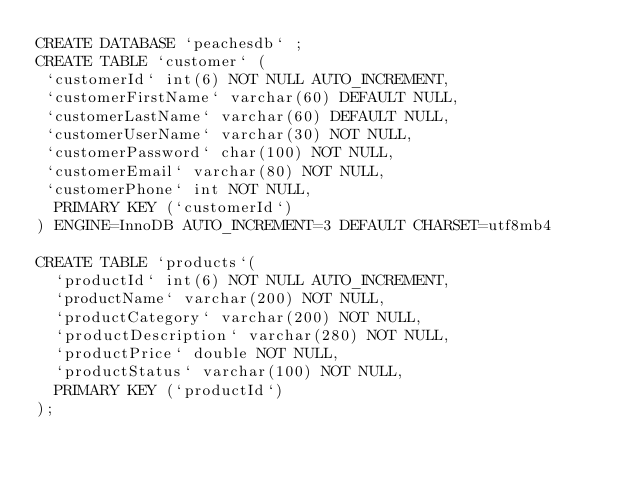Convert code to text. <code><loc_0><loc_0><loc_500><loc_500><_SQL_>CREATE DATABASE `peachesdb` ;	
CREATE TABLE `customer` (
 `customerId` int(6) NOT NULL AUTO_INCREMENT,
 `customerFirstName` varchar(60) DEFAULT NULL,
 `customerLastName` varchar(60) DEFAULT NULL,
 `customerUserName` varchar(30) NOT NULL,
 `customerPassword` char(100) NOT NULL,
 `customerEmail` varchar(80) NOT NULL,
 `customerPhone` int NOT NULL,
  PRIMARY KEY (`customerId`)
) ENGINE=InnoDB AUTO_INCREMENT=3 DEFAULT CHARSET=utf8mb4

CREATE TABLE `products`(
  `productId` int(6) NOT NULL AUTO_INCREMENT,
  `productName` varchar(200) NOT NULL,
  `productCategory` varchar(200) NOT NULL,
  `productDescription` varchar(280) NOT NULL,
  `productPrice` double NOT NULL,
  `productStatus` varchar(100) NOT NULL, 
  PRIMARY KEY (`productId`)
);</code> 